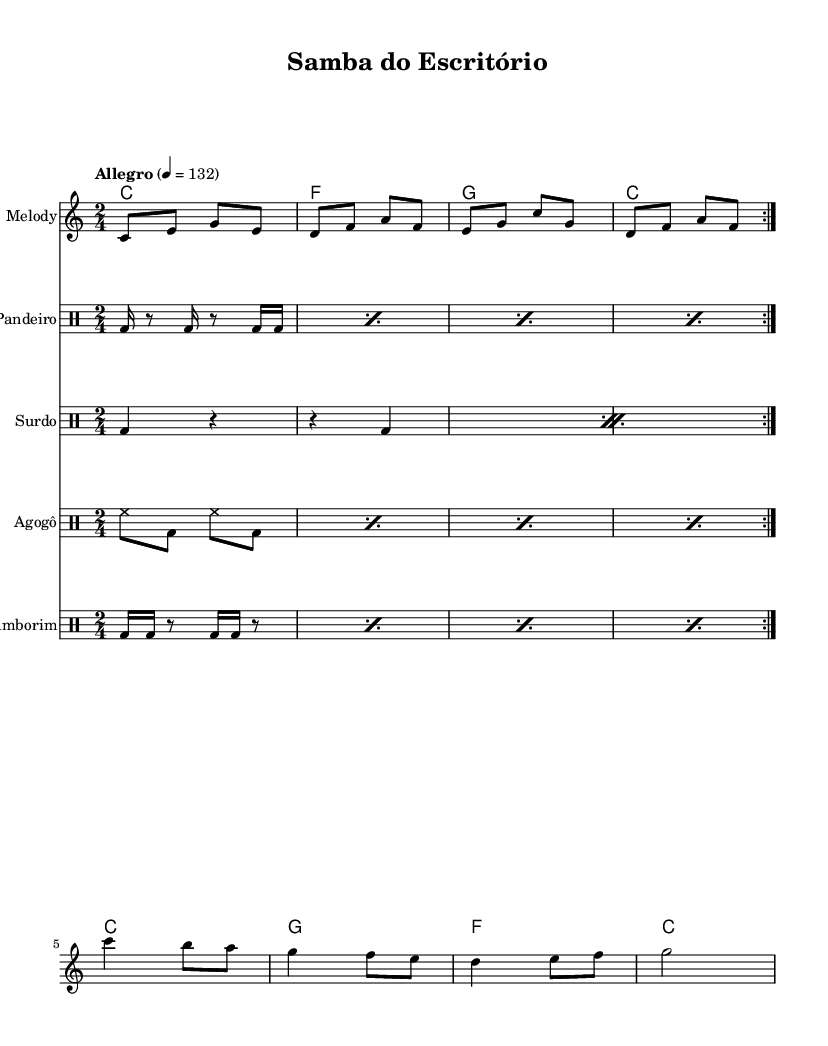What is the key signature of this music? The key signature is C major, which has no sharps or flats.
Answer: C major What is the time signature of this piece? The time signature is indicated as 2/4, meaning there are two beats per measure and the quarter note gets one beat.
Answer: 2/4 What is the tempo marking of this composition? The tempo marking indicates the piece should be played at "Allegro," specifically at a tempo of 132 beats per minute.
Answer: Allegro How many measures are in the verse section? The verse section is repeated twice, and each repeat consists of 4 measures, making a total of 8 measures in the verse.
Answer: 8 measures What are the main instruments used in this samba piece? The main instruments include the Melody, Pandeiro, Surdo, Agogô, and Tamborim, showcasing the rhythmic complexity typical of samba.
Answer: Melody, Pandeiro, Surdo, Agogô, Tamborim What cultural context does this music represent? This music represents Brazilian culture, specifically the energetic samba style often associated with celebrations and festivities.
Answer: Brazilian culture 